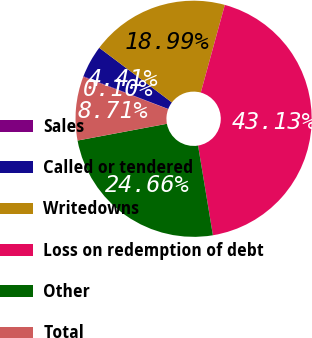Convert chart. <chart><loc_0><loc_0><loc_500><loc_500><pie_chart><fcel>Sales<fcel>Called or tendered<fcel>Writedowns<fcel>Loss on redemption of debt<fcel>Other<fcel>Total<nl><fcel>0.1%<fcel>4.41%<fcel>18.99%<fcel>43.13%<fcel>24.66%<fcel>8.71%<nl></chart> 